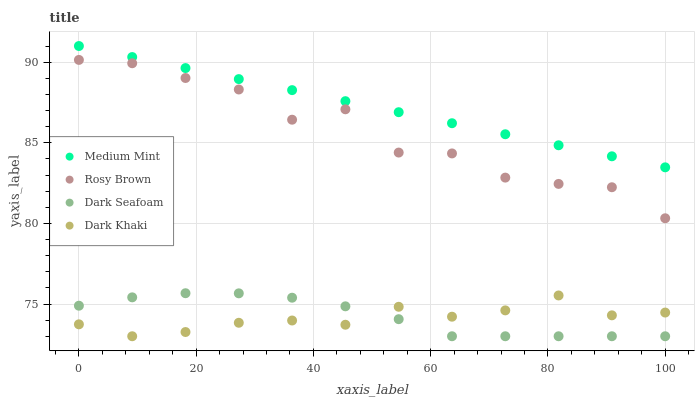Does Dark Khaki have the minimum area under the curve?
Answer yes or no. Yes. Does Medium Mint have the maximum area under the curve?
Answer yes or no. Yes. Does Dark Seafoam have the minimum area under the curve?
Answer yes or no. No. Does Dark Seafoam have the maximum area under the curve?
Answer yes or no. No. Is Medium Mint the smoothest?
Answer yes or no. Yes. Is Rosy Brown the roughest?
Answer yes or no. Yes. Is Dark Khaki the smoothest?
Answer yes or no. No. Is Dark Khaki the roughest?
Answer yes or no. No. Does Dark Khaki have the lowest value?
Answer yes or no. Yes. Does Rosy Brown have the lowest value?
Answer yes or no. No. Does Medium Mint have the highest value?
Answer yes or no. Yes. Does Dark Seafoam have the highest value?
Answer yes or no. No. Is Rosy Brown less than Medium Mint?
Answer yes or no. Yes. Is Medium Mint greater than Dark Khaki?
Answer yes or no. Yes. Does Dark Seafoam intersect Dark Khaki?
Answer yes or no. Yes. Is Dark Seafoam less than Dark Khaki?
Answer yes or no. No. Is Dark Seafoam greater than Dark Khaki?
Answer yes or no. No. Does Rosy Brown intersect Medium Mint?
Answer yes or no. No. 